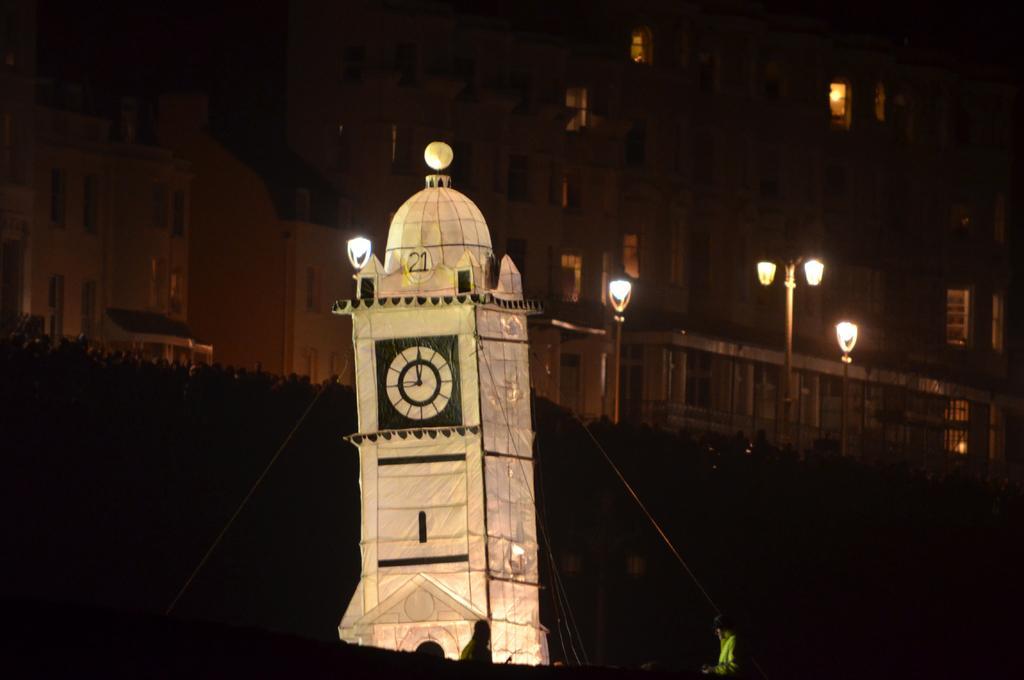Describe this image in one or two sentences. In this image I see number of buildings and I see the light poles over here and I see the clock tower over here and it is a bit dark over here. 